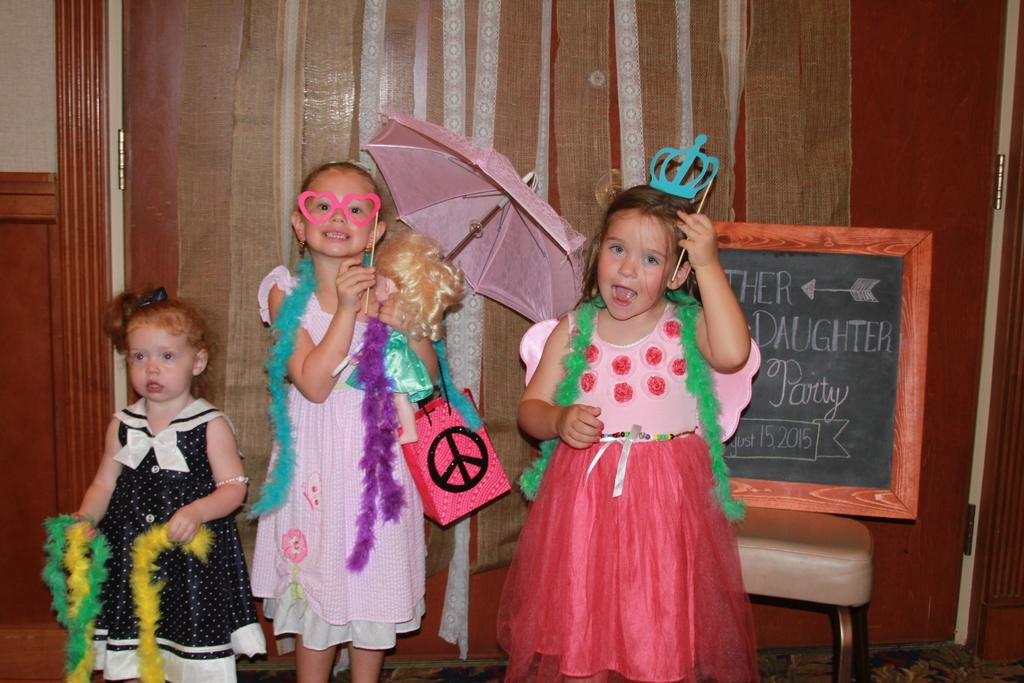How many girls are present in the image? There are three girls in the image. What objects can be seen in the image besides the girls? There is a bag, an umbrella, a board, a stool, party objects, and curtains in the image. What type of objects might be used for sitting or standing in the image? The stool can be used for sitting in the image. What is the background of the image? There is a wall in the background of the image. What type of beam can be seen supporting the field in the image? There is no beam or field present in the image. What type of pot is visible on the wall in the image? There is no pot visible on the wall in the image. 